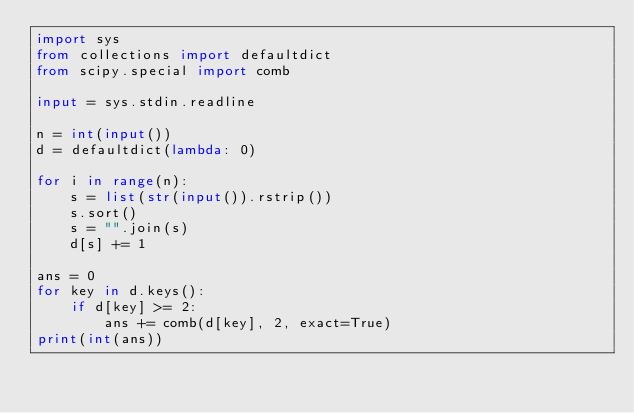<code> <loc_0><loc_0><loc_500><loc_500><_Python_>import sys
from collections import defaultdict
from scipy.special import comb

input = sys.stdin.readline

n = int(input())
d = defaultdict(lambda: 0)

for i in range(n):
    s = list(str(input()).rstrip())
    s.sort()
    s = "".join(s)
    d[s] += 1   

ans = 0
for key in d.keys():
    if d[key] >= 2:
        ans += comb(d[key], 2, exact=True)
print(int(ans))</code> 